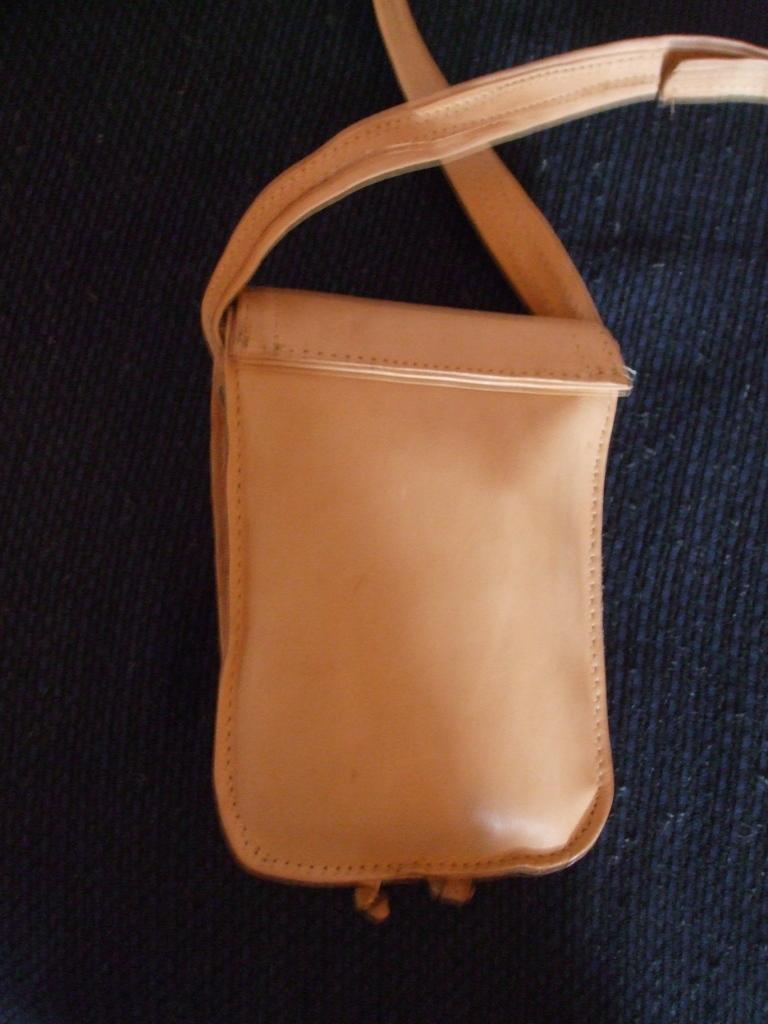What color is the bag that is visible in the image? There is an orange color bag in the image. What feature of the bag allows it to be carried easily? The bag has a strap. What type of bird can be seen sitting on the bag in the image? There are no birds visible in the image, including robins. 